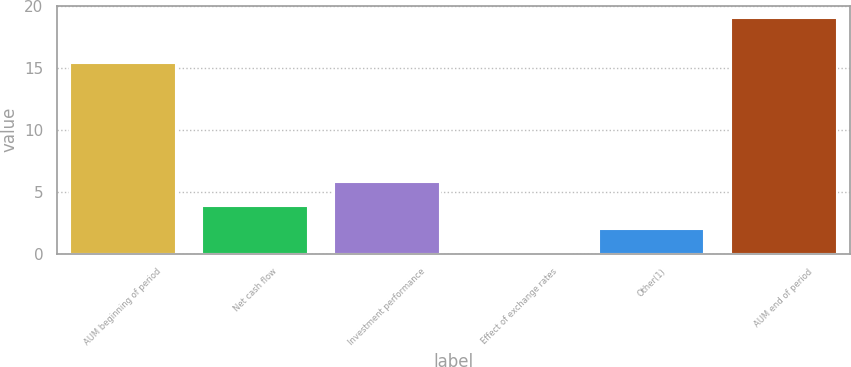Convert chart to OTSL. <chart><loc_0><loc_0><loc_500><loc_500><bar_chart><fcel>AUM beginning of period<fcel>Net cash flow<fcel>Investment performance<fcel>Effect of exchange rates<fcel>Other(1)<fcel>AUM end of period<nl><fcel>15.4<fcel>3.9<fcel>5.8<fcel>0.1<fcel>2<fcel>19.1<nl></chart> 